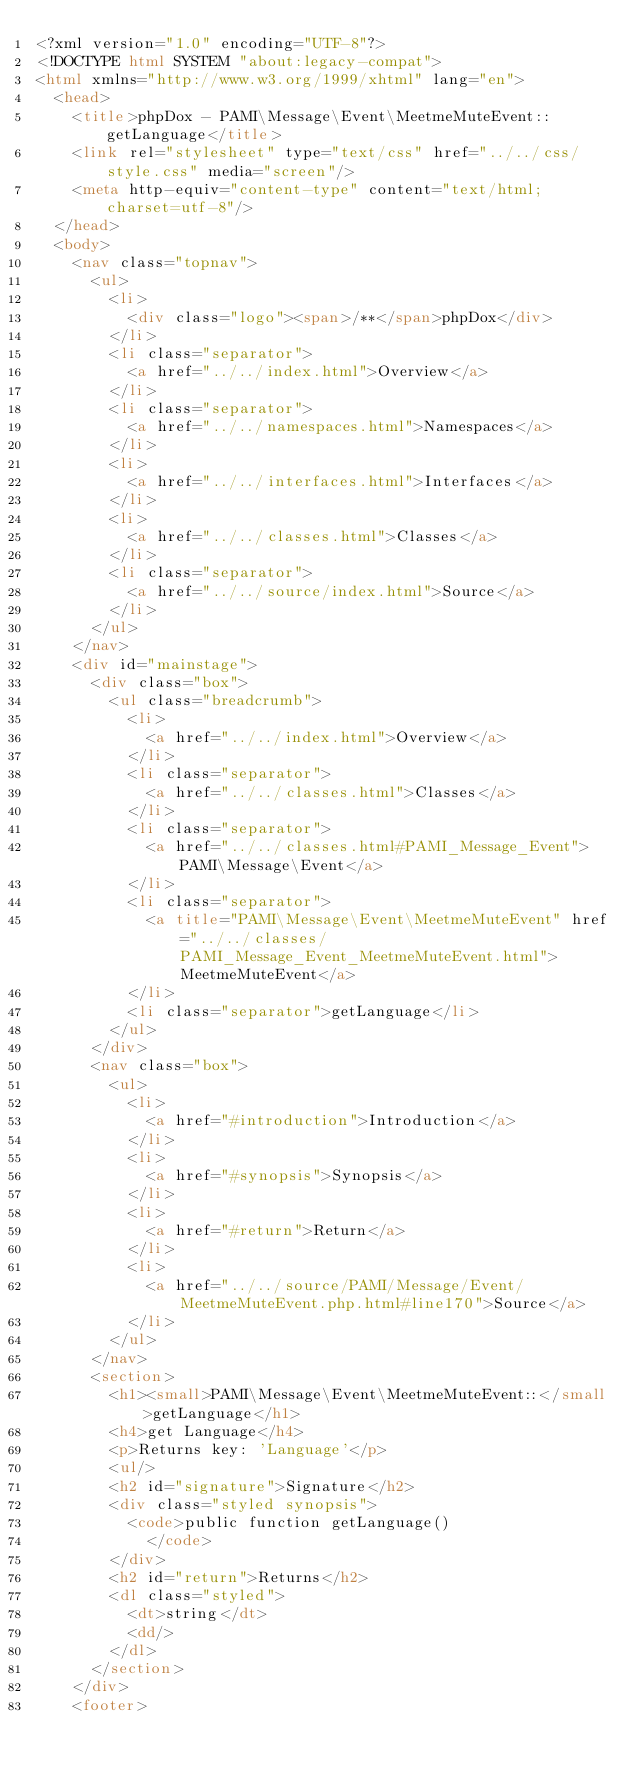<code> <loc_0><loc_0><loc_500><loc_500><_HTML_><?xml version="1.0" encoding="UTF-8"?>
<!DOCTYPE html SYSTEM "about:legacy-compat">
<html xmlns="http://www.w3.org/1999/xhtml" lang="en">
  <head>
    <title>phpDox - PAMI\Message\Event\MeetmeMuteEvent::getLanguage</title>
    <link rel="stylesheet" type="text/css" href="../../css/style.css" media="screen"/>
    <meta http-equiv="content-type" content="text/html; charset=utf-8"/>
  </head>
  <body>
    <nav class="topnav">
      <ul>
        <li>
          <div class="logo"><span>/**</span>phpDox</div>
        </li>
        <li class="separator">
          <a href="../../index.html">Overview</a>
        </li>
        <li class="separator">
          <a href="../../namespaces.html">Namespaces</a>
        </li>
        <li>
          <a href="../../interfaces.html">Interfaces</a>
        </li>
        <li>
          <a href="../../classes.html">Classes</a>
        </li>
        <li class="separator">
          <a href="../../source/index.html">Source</a>
        </li>
      </ul>
    </nav>
    <div id="mainstage">
      <div class="box">
        <ul class="breadcrumb">
          <li>
            <a href="../../index.html">Overview</a>
          </li>
          <li class="separator">
            <a href="../../classes.html">Classes</a>
          </li>
          <li class="separator">
            <a href="../../classes.html#PAMI_Message_Event">PAMI\Message\Event</a>
          </li>
          <li class="separator">
            <a title="PAMI\Message\Event\MeetmeMuteEvent" href="../../classes/PAMI_Message_Event_MeetmeMuteEvent.html">MeetmeMuteEvent</a>
          </li>
          <li class="separator">getLanguage</li>
        </ul>
      </div>
      <nav class="box">
        <ul>
          <li>
            <a href="#introduction">Introduction</a>
          </li>
          <li>
            <a href="#synopsis">Synopsis</a>
          </li>
          <li>
            <a href="#return">Return</a>
          </li>
          <li>
            <a href="../../source/PAMI/Message/Event/MeetmeMuteEvent.php.html#line170">Source</a>
          </li>
        </ul>
      </nav>
      <section>
        <h1><small>PAMI\Message\Event\MeetmeMuteEvent::</small>getLanguage</h1>
        <h4>get Language</h4>
        <p>Returns key: 'Language'</p>
        <ul/>
        <h2 id="signature">Signature</h2>
        <div class="styled synopsis">
          <code>public function getLanguage()
            </code>
        </div>
        <h2 id="return">Returns</h2>
        <dl class="styled">
          <dt>string</dt>
          <dd/>
        </dl>
      </section>
    </div>
    <footer></code> 